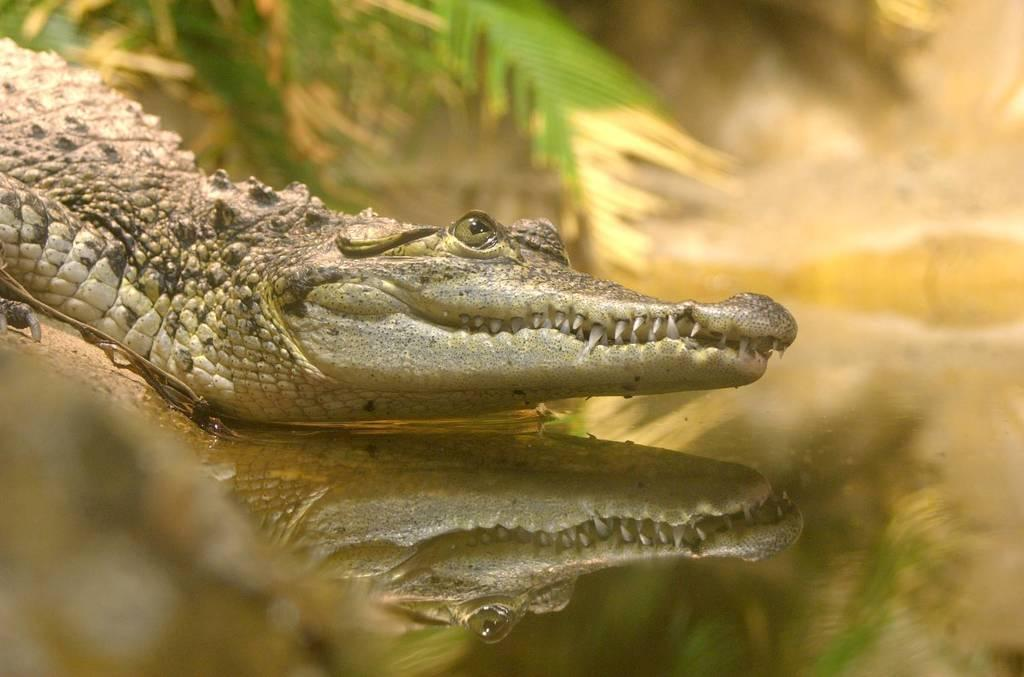What animal is present in the image? There is a crocodile in the image. What is at the bottom of the image? There is water at the bottom of the image. What can be seen in the background of the image? There are trees in the background of the image. What type of bulb is used to light up the crocodile's chin in the image? There is no bulb or lighting present in the image, and the crocodile's chin is not illuminated. 